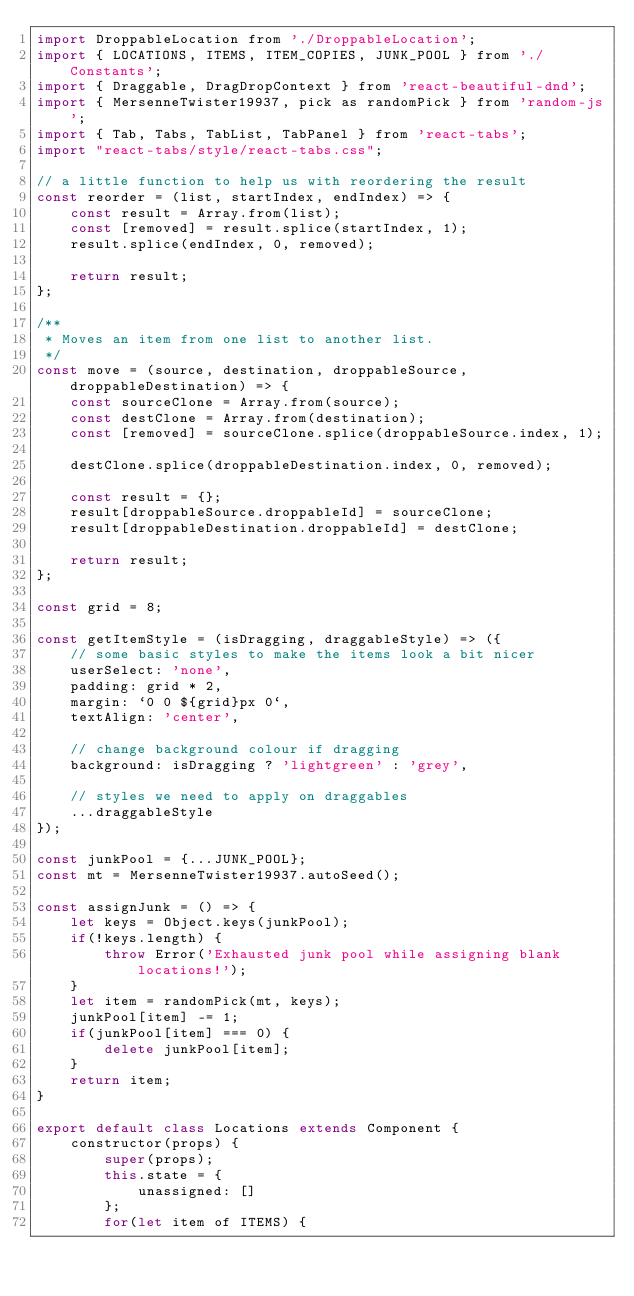<code> <loc_0><loc_0><loc_500><loc_500><_JavaScript_>import DroppableLocation from './DroppableLocation';
import { LOCATIONS, ITEMS, ITEM_COPIES, JUNK_POOL } from './Constants';
import { Draggable, DragDropContext } from 'react-beautiful-dnd';
import { MersenneTwister19937, pick as randomPick } from 'random-js';
import { Tab, Tabs, TabList, TabPanel } from 'react-tabs';
import "react-tabs/style/react-tabs.css";

// a little function to help us with reordering the result
const reorder = (list, startIndex, endIndex) => {
    const result = Array.from(list);
    const [removed] = result.splice(startIndex, 1);
    result.splice(endIndex, 0, removed);

    return result;
};

/**
 * Moves an item from one list to another list.
 */
const move = (source, destination, droppableSource, droppableDestination) => {
    const sourceClone = Array.from(source);
    const destClone = Array.from(destination);
    const [removed] = sourceClone.splice(droppableSource.index, 1);

    destClone.splice(droppableDestination.index, 0, removed);

    const result = {};
    result[droppableSource.droppableId] = sourceClone;
    result[droppableDestination.droppableId] = destClone;

    return result;
};

const grid = 8;

const getItemStyle = (isDragging, draggableStyle) => ({
    // some basic styles to make the items look a bit nicer
    userSelect: 'none',
    padding: grid * 2,
    margin: `0 0 ${grid}px 0`,
    textAlign: 'center',

    // change background colour if dragging
    background: isDragging ? 'lightgreen' : 'grey',

    // styles we need to apply on draggables
    ...draggableStyle
});

const junkPool = {...JUNK_POOL};
const mt = MersenneTwister19937.autoSeed();

const assignJunk = () => {
    let keys = Object.keys(junkPool);
    if(!keys.length) {
        throw Error('Exhausted junk pool while assigning blank locations!');
    }
    let item = randomPick(mt, keys);
    junkPool[item] -= 1;
    if(junkPool[item] === 0) {
        delete junkPool[item];
    }
    return item;
}

export default class Locations extends Component {
    constructor(props) {
        super(props);
        this.state = {
            unassigned: []
        };
        for(let item of ITEMS) {</code> 